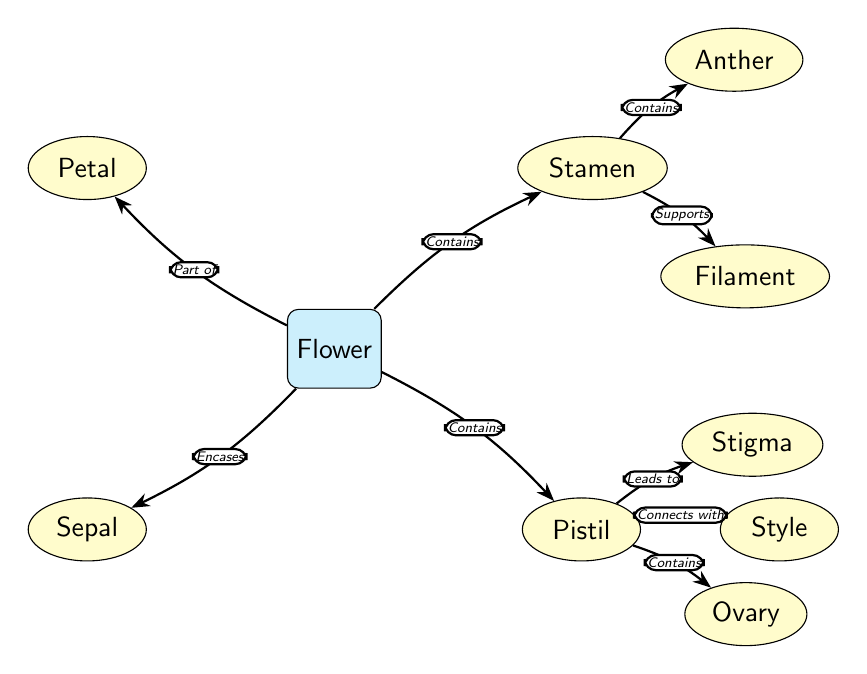What is the central part of the flower? The diagram designates the "Flower" as the main node in the center, clearly indicating it as the focus of the structure.
Answer: Flower How many main components are shown in the flower? The diagram displays four main components branching from the central "Flower" node: Petal, Sepal, Stamen, and Pistil. Counting these gives a total of four components.
Answer: 4 What part of the flower encapsulates the sepal? The diagram shows an arrow labeled "Encases" connecting the main node "Flower" to the "Sepal," indicating that the sepal is encased by the flower.
Answer: Flower What are the two sub-parts of the stamen? The diagram illustrates that the stamen consists of two parts: "Anther" and "Filament," as indicated by the connections labeled "Contains" and "Supports" from the stamen node.
Answer: Anther, Filament Which part of the pistil leads to the stigma? In the diagram, there is a connection labeled "Leads to" from the "Pistil" node to the "Stigma" node, indicating that the stigma comes directly after the pistil.
Answer: Stigma Explain the relationship between the stamen and the anther. The diagram shows that the stamen "Contains" the anther, denoted by an arrow that illustrates a direct connection from the stamen to the anther. This means the anther is a part of the stamen.
Answer: Contains What is the role of the style in the pistil? The diagram indicates a connection labeled "Connects with" between the "Pistil" and "Style," suggesting that the style is a component that connects and extends from the pistil.
Answer: Connects with Which node is below the flower and on the left side? The diagram positions the "Sepal" node directly below the main "Flower" node and to the left, signifying its location relative to the flower.
Answer: Sepal What function does the filament serve in the flower's anatomy? According to the diagram, the filament is labeled with "Supports," which describes its functional role as a supportive structure connecting to the anther in the stamen.
Answer: Supports 